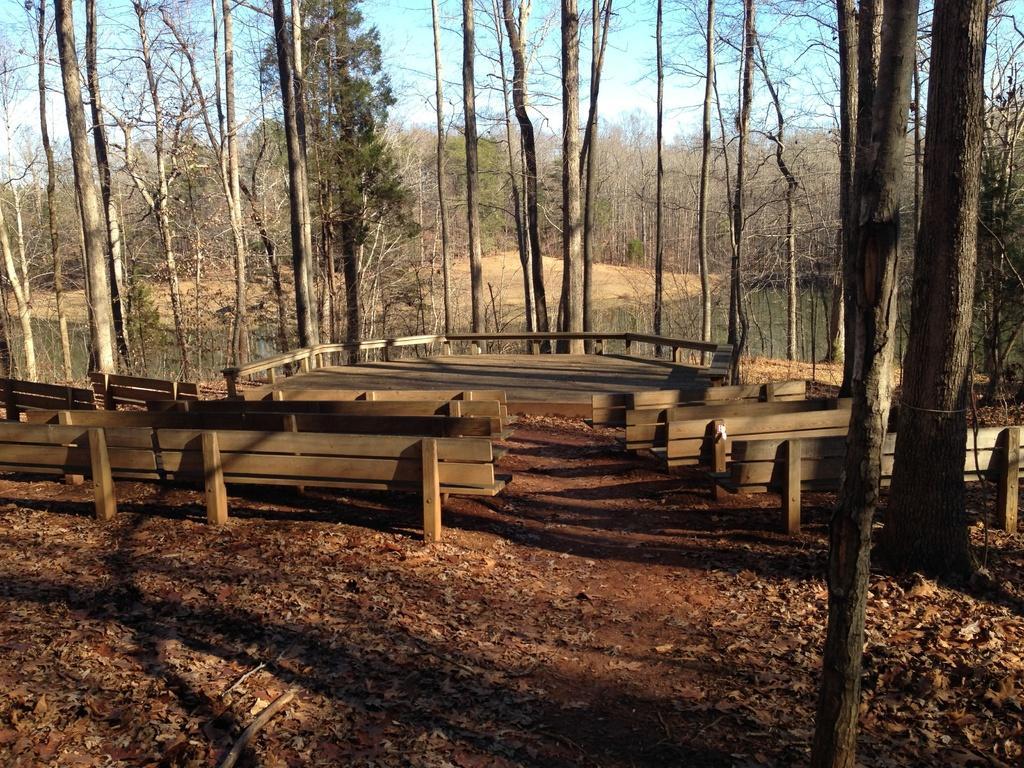Describe this image in one or two sentences. In the middle of the picture, we see wooden benches. At the bottom of the picture, we see dried leaves and twigs. There are many trees in the background. We see water in the pond. At the top of the picture, we see the sky. 